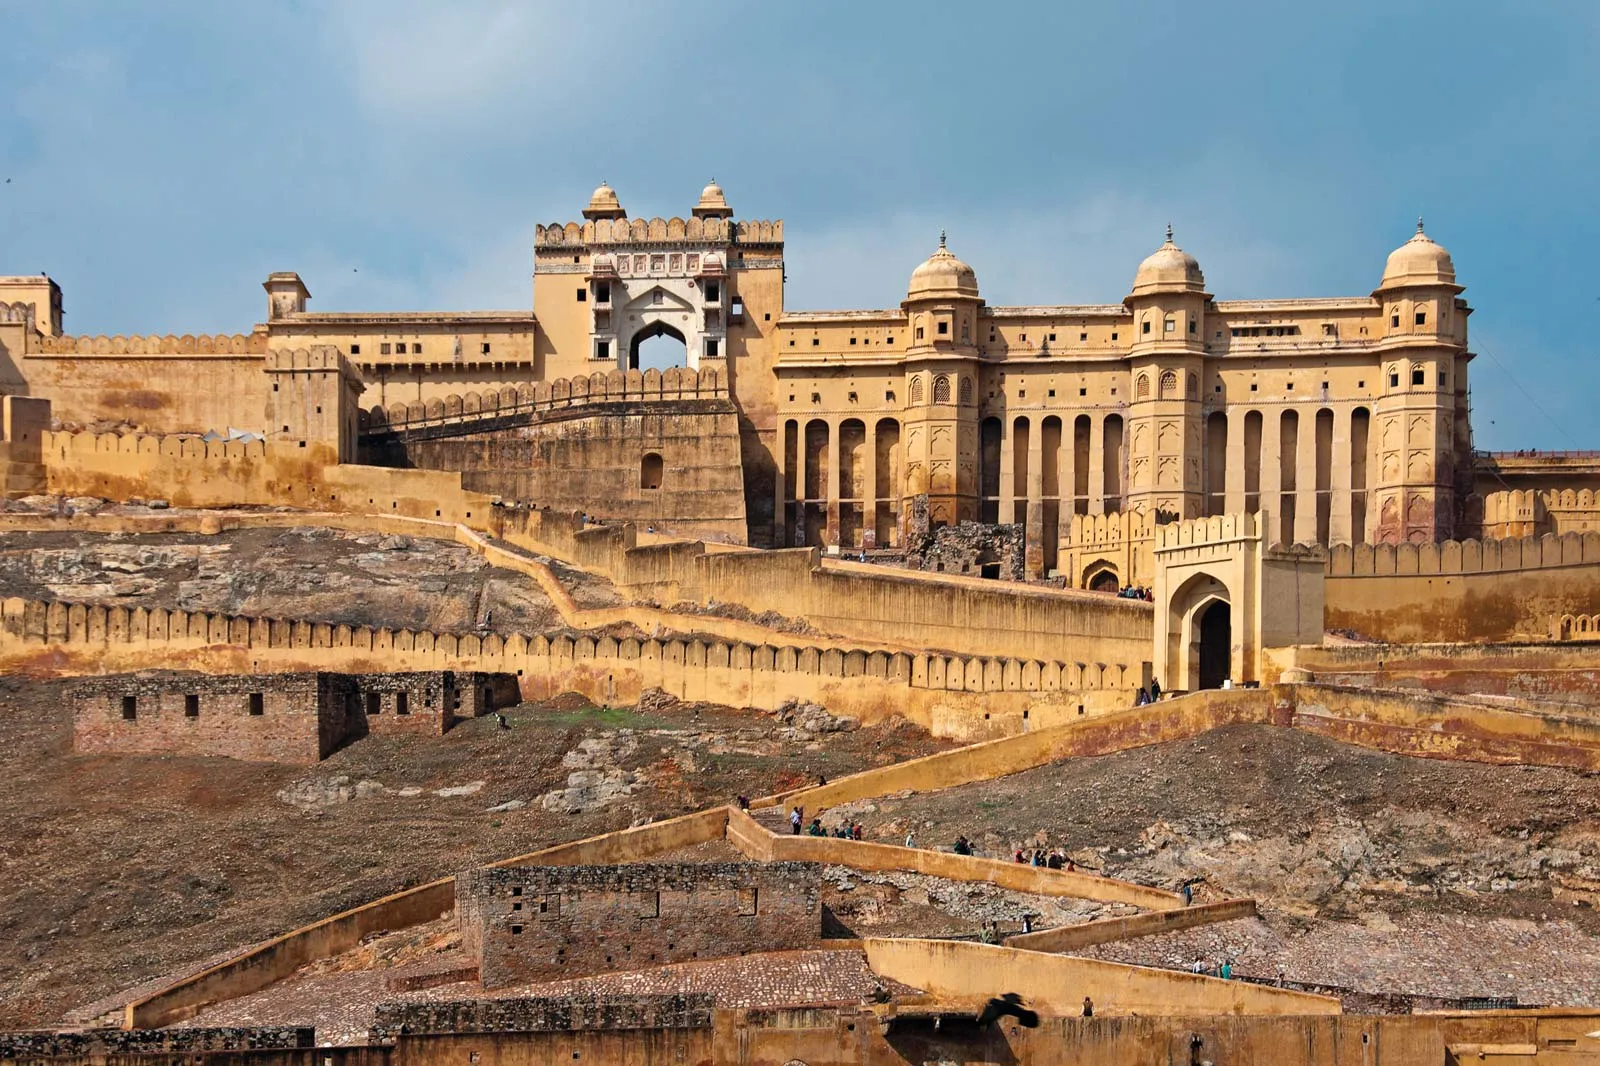What historical significance does this fort hold? Amber Fort holds immense historical significance as it was the stronghold of the Kachwaha Rajputs, who ruled over Amber (now a part of Jaipur, Rajasthan) before the capital was moved to Jaipur in 1727. It is a testament to the strategic military architecture and the splendor of Rajput and Mughal styles combined. Built by Raja Man Singh I in 1592 and later expanded by subsequent rulers, the fort witnessed key historical events, including wars, alliances, and the flourishing culture of the Rajput kingdom. Its robust architecture and opulent design reflect the wealth, power, and artistic excellence of the Rajputana era. If you could travel back in time to witness a day at Amber Fort, what would you see? Traveling back in time to a day at Amber Fort would be like stepping into a page of history filled with vibrance and grandeur. The day would begin with early morning prayers by the royals and the ceremonial court routines in the Diwan-e-Aam, where the Maharaja would address his subjects. You would witness bustling courtyards with ministers, soldiers, and servants going about their daily duties. The smell of rich traditional Rajasthani cuisine wafting from the royal kitchens would fill the air. Throughout the day, the fort would be resplendent with the sounds of traditional music and the ambiance of royal banquets and festivities. Intricate palanquins, golden thrones, and richly adorned chambers would showcase the opulence of the time. Evening would fall with cultural entertainments such as dance, music, and poetry in the splendid Sheesh Mahal, illuminated by thousands of flickering candles reflecting off the mirrors, creating a mesmerizing effect. The air would be thick with the history, culture, and richness of the bygone era. 